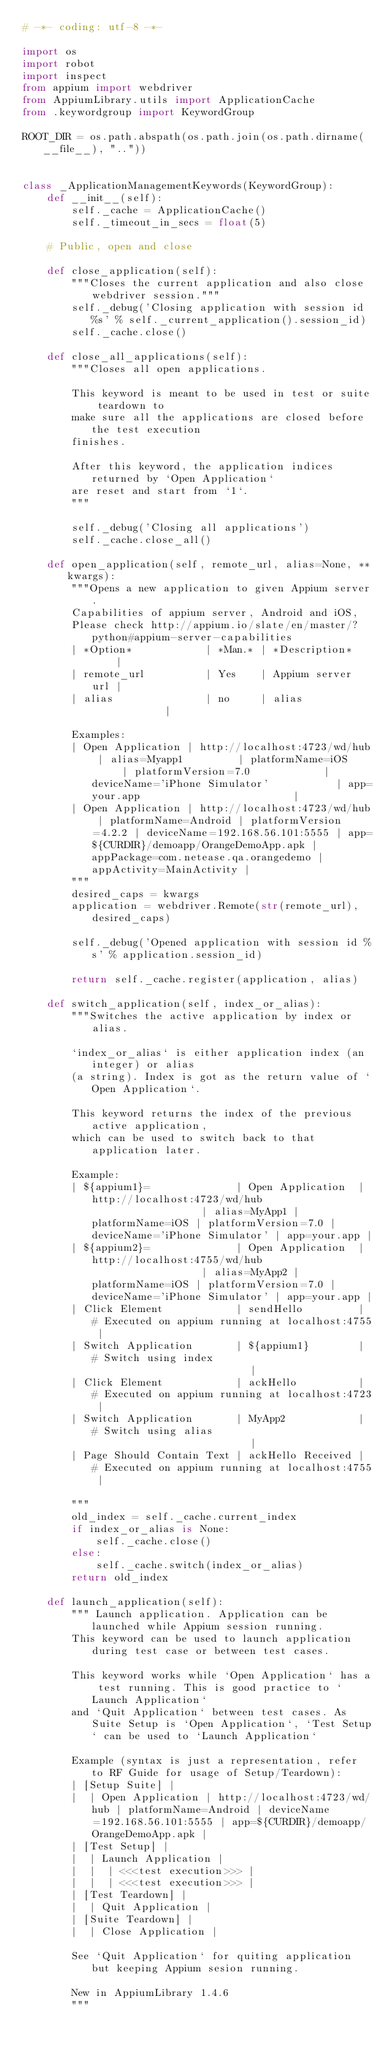<code> <loc_0><loc_0><loc_500><loc_500><_Python_># -*- coding: utf-8 -*-

import os
import robot
import inspect
from appium import webdriver
from AppiumLibrary.utils import ApplicationCache
from .keywordgroup import KeywordGroup

ROOT_DIR = os.path.abspath(os.path.join(os.path.dirname(__file__), ".."))


class _ApplicationManagementKeywords(KeywordGroup):
    def __init__(self):
        self._cache = ApplicationCache()
        self._timeout_in_secs = float(5)

    # Public, open and close

    def close_application(self):
        """Closes the current application and also close webdriver session."""
        self._debug('Closing application with session id %s' % self._current_application().session_id)
        self._cache.close()

    def close_all_applications(self):
        """Closes all open applications.

        This keyword is meant to be used in test or suite teardown to
        make sure all the applications are closed before the test execution
        finishes.

        After this keyword, the application indices returned by `Open Application`
        are reset and start from `1`.
        """

        self._debug('Closing all applications')
        self._cache.close_all()

    def open_application(self, remote_url, alias=None, **kwargs):
        """Opens a new application to given Appium server.
        Capabilities of appium server, Android and iOS,
        Please check http://appium.io/slate/en/master/?python#appium-server-capabilities
        | *Option*            | *Man.* | *Description*     |
        | remote_url          | Yes    | Appium server url |
        | alias               | no     | alias             |

        Examples:
        | Open Application | http://localhost:4723/wd/hub | alias=Myapp1         | platformName=iOS      | platformVersion=7.0            | deviceName='iPhone Simulator'           | app=your.app                         |
        | Open Application | http://localhost:4723/wd/hub | platformName=Android | platformVersion=4.2.2 | deviceName=192.168.56.101:5555 | app=${CURDIR}/demoapp/OrangeDemoApp.apk | appPackage=com.netease.qa.orangedemo | appActivity=MainActivity |
        """
        desired_caps = kwargs
        application = webdriver.Remote(str(remote_url), desired_caps)

        self._debug('Opened application with session id %s' % application.session_id)

        return self._cache.register(application, alias)

    def switch_application(self, index_or_alias):
        """Switches the active application by index or alias.

        `index_or_alias` is either application index (an integer) or alias
        (a string). Index is got as the return value of `Open Application`.

        This keyword returns the index of the previous active application,
        which can be used to switch back to that application later.

        Example:
        | ${appium1}=              | Open Application  | http://localhost:4723/wd/hub                   | alias=MyApp1 | platformName=iOS | platformVersion=7.0 | deviceName='iPhone Simulator' | app=your.app |
        | ${appium2}=              | Open Application  | http://localhost:4755/wd/hub                   | alias=MyApp2 | platformName=iOS | platformVersion=7.0 | deviceName='iPhone Simulator' | app=your.app |
        | Click Element            | sendHello         | # Executed on appium running at localhost:4755 |
        | Switch Application       | ${appium1}        | # Switch using index                           |
        | Click Element            | ackHello          | # Executed on appium running at localhost:4723 |
        | Switch Application       | MyApp2            | # Switch using alias                           |
        | Page Should Contain Text | ackHello Received | # Executed on appium running at localhost:4755 |

        """
        old_index = self._cache.current_index
        if index_or_alias is None:
            self._cache.close()
        else:
            self._cache.switch(index_or_alias)
        return old_index

    def launch_application(self):
        """ Launch application. Application can be launched while Appium session running.
        This keyword can be used to launch application during test case or between test cases.

        This keyword works while `Open Application` has a test running. This is good practice to `Launch Application`
        and `Quit Application` between test cases. As Suite Setup is `Open Application`, `Test Setup` can be used to `Launch Application`

        Example (syntax is just a representation, refer to RF Guide for usage of Setup/Teardown):
        | [Setup Suite] |
        |  | Open Application | http://localhost:4723/wd/hub | platformName=Android | deviceName=192.168.56.101:5555 | app=${CURDIR}/demoapp/OrangeDemoApp.apk |
        | [Test Setup] |
        |  | Launch Application |
        |  |  | <<<test execution>>> |
        |  |  | <<<test execution>>> |
        | [Test Teardown] |
        |  | Quit Application |
        | [Suite Teardown] |
        |  | Close Application |

        See `Quit Application` for quiting application but keeping Appium sesion running.

        New in AppiumLibrary 1.4.6
        """</code> 